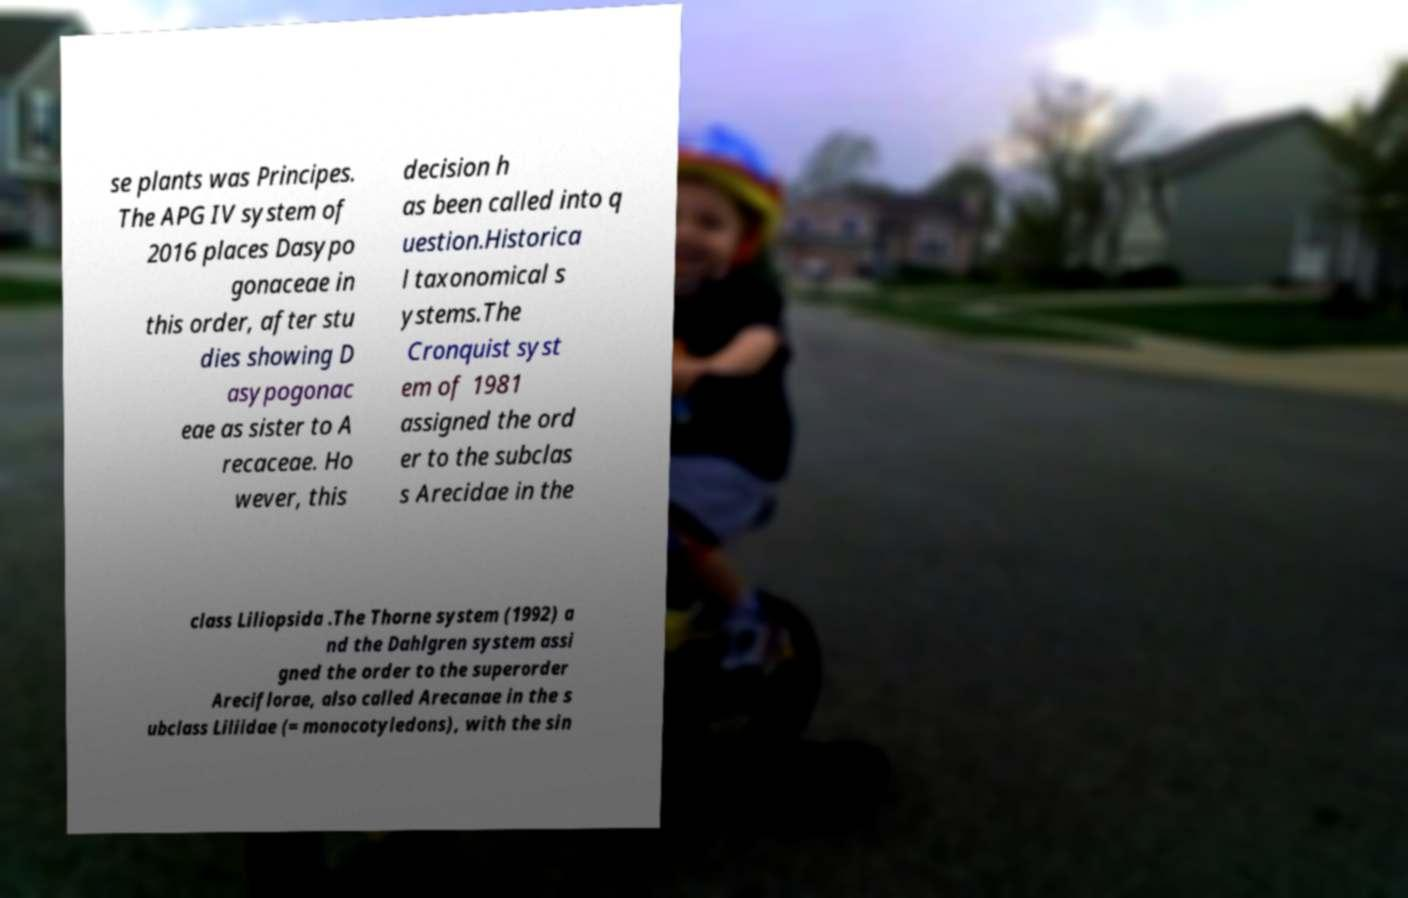Can you read and provide the text displayed in the image?This photo seems to have some interesting text. Can you extract and type it out for me? se plants was Principes. The APG IV system of 2016 places Dasypo gonaceae in this order, after stu dies showing D asypogonac eae as sister to A recaceae. Ho wever, this decision h as been called into q uestion.Historica l taxonomical s ystems.The Cronquist syst em of 1981 assigned the ord er to the subclas s Arecidae in the class Liliopsida .The Thorne system (1992) a nd the Dahlgren system assi gned the order to the superorder Areciflorae, also called Arecanae in the s ubclass Liliidae (= monocotyledons), with the sin 